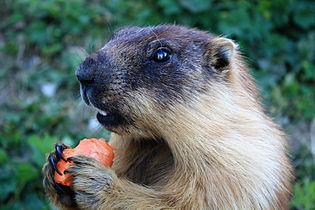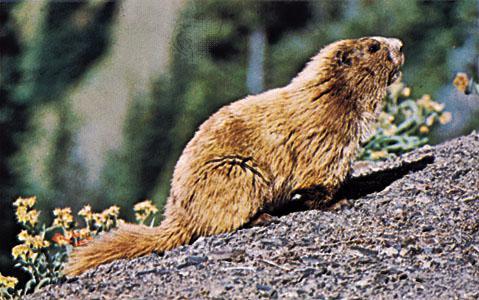The first image is the image on the left, the second image is the image on the right. Evaluate the accuracy of this statement regarding the images: "The marmot in the left image is upright with food clasped in its paws, and the marmot on the right is standing on all fours on the ground.". Is it true? Answer yes or no. Yes. The first image is the image on the left, the second image is the image on the right. Assess this claim about the two images: "The animal in the image on the left is holding something to its mouth.". Correct or not? Answer yes or no. Yes. 